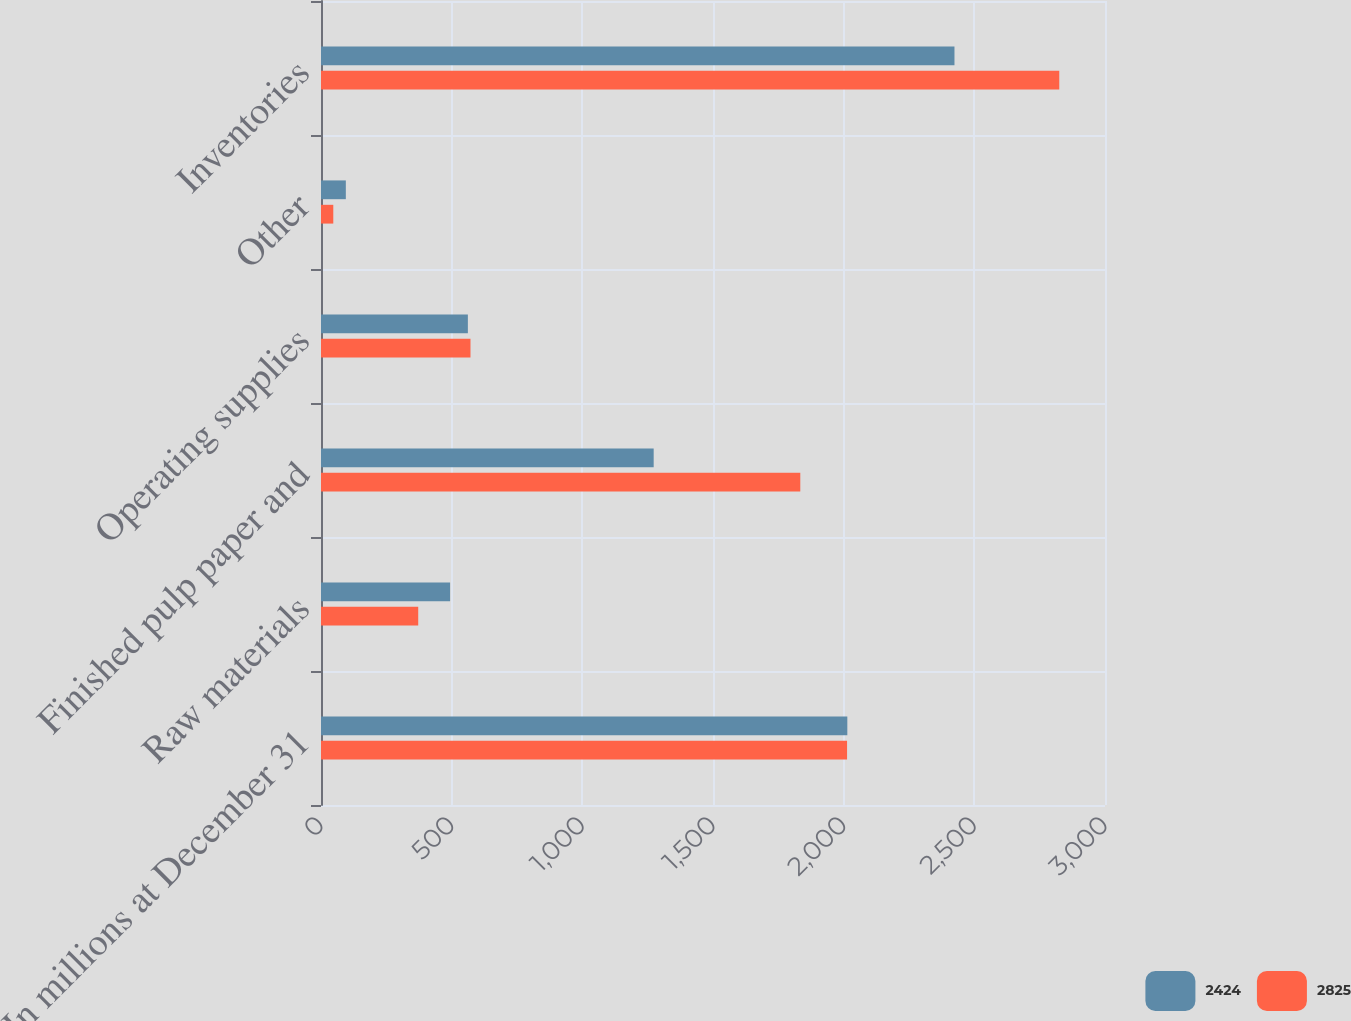Convert chart. <chart><loc_0><loc_0><loc_500><loc_500><stacked_bar_chart><ecel><fcel>In millions at December 31<fcel>Raw materials<fcel>Finished pulp paper and<fcel>Operating supplies<fcel>Other<fcel>Inventories<nl><fcel>2424<fcel>2014<fcel>494<fcel>1273<fcel>562<fcel>95<fcel>2424<nl><fcel>2825<fcel>2013<fcel>372<fcel>1834<fcel>572<fcel>47<fcel>2825<nl></chart> 